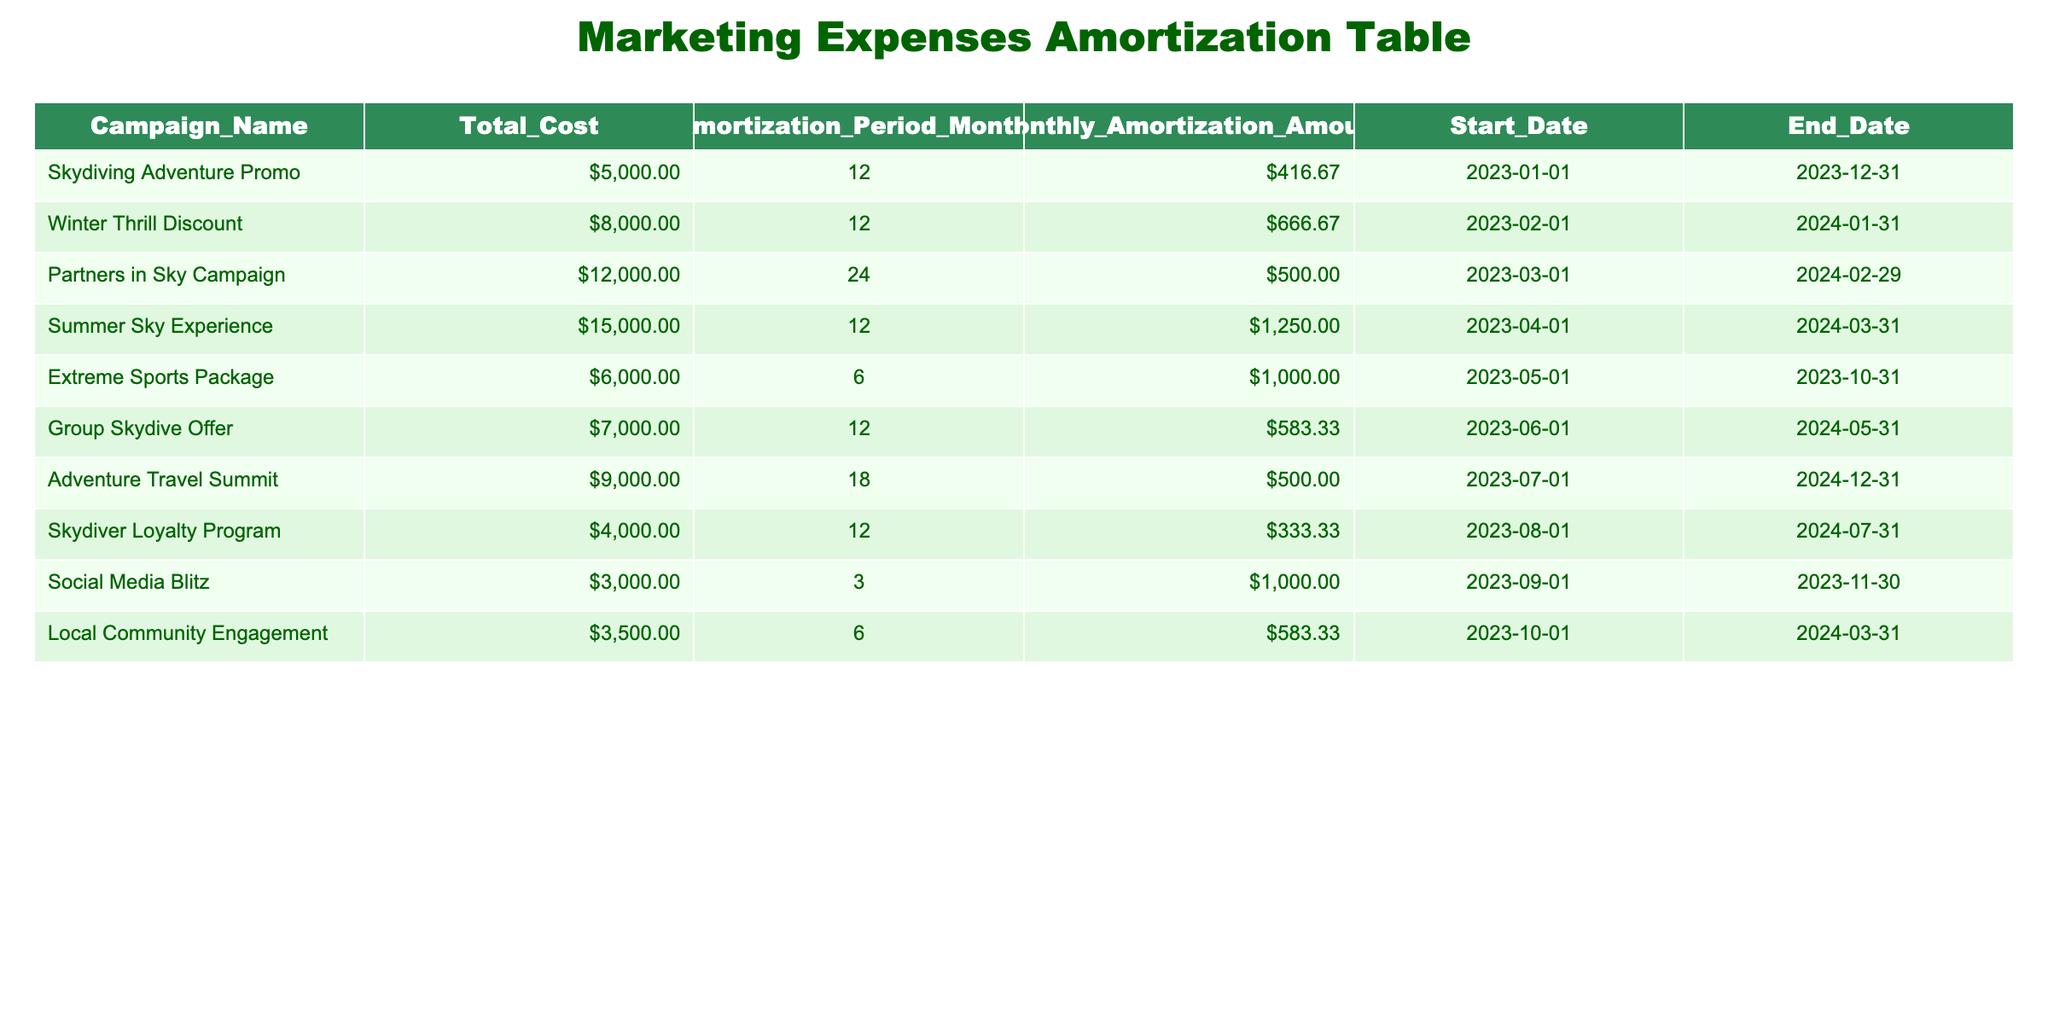What is the total cost of the Winter Thrill Discount campaign? The amount listed under the Total Cost column for the Winter Thrill Discount campaign is $8,000.
Answer: $8,000 How many months does the Extreme Sports Package campaign amortize over? The Amortization Period Months column shows that the Extreme Sports Package campaign amortizes over 6 months.
Answer: 6 months What is the average monthly amortization amount across all campaigns? To calculate the average, sum the Monthly Amortization Amounts ($416.67 + $666.67 + $500.00 + $1,250.00 + $1,000.00 + $583.33 + $500.00 + $333.33 + $1,000.00 + $583.33 = $6,333.33) and divide by the number of campaigns (10). Thus, the average monthly amortization amount is $6,333.33 / 10 = $633.33.
Answer: $633.33 Is the Summer Sky Experience campaign amortizing for a longer period than the Skydiver Loyalty Program? The Summer Sky Experience campaign has an amortization period of 12 months, while the Skydiver Loyalty Program also has an amortization period of 12 months. Since both are the same, the answer is no.
Answer: No Which campaign has the highest total cost? By reviewing the Total Cost column, the Partners in Sky Campaign has the highest total cost of $12,000 compared to all other campaigns.
Answer: $12,000 What is the total monthly amortization amount for all campaigns combined? First, sum the Monthly Amortization Amounts ($416.67 + $666.67 + $500.00 + $1,250.00 + $1,000.00 + $583.33 + $500.00 + $333.33 + $1,000.00 + $583.33 = $6,333.33) gives the total monthly amortization amount for all campaigns combined.
Answer: $6,333.33 Does the Campaign named Social Media Blitz have a longer amortization period than the Local Community Engagement campaign? The Social Media Blitz campaign has an amortization period of 3 months while the Local Community Engagement campaign has an amortization period of 6 months. Since 3 months is not greater than 6 months, the answer is no.
Answer: No What percentage of the total costs does the Skydiving Adventure Promo represent among all campaigns? The total cost of all campaigns is $5000 + $8000 + $12000 + $15000 + $6000 + $7000 + $9000 + $4000 + $3000 + $3500 = $65000. The proportion of Skydiving Adventure Promo is thus ($5000 / $65000) * 100 ≈ 7.69%.
Answer: 7.69% 